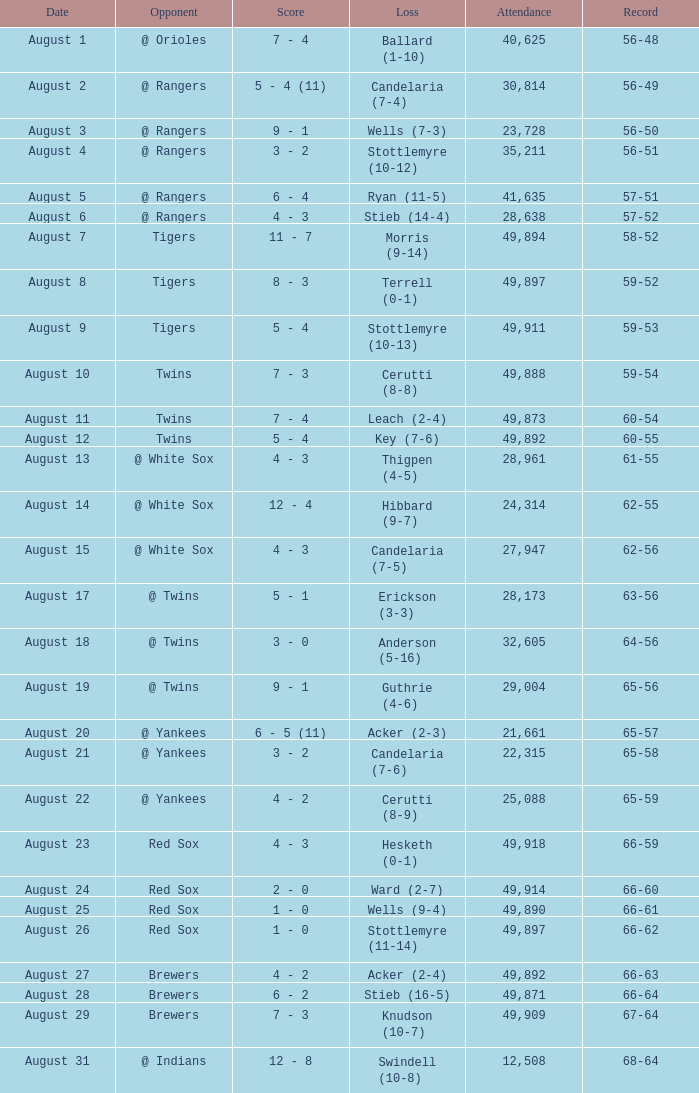What was the Attendance high on August 28? 49871.0. 